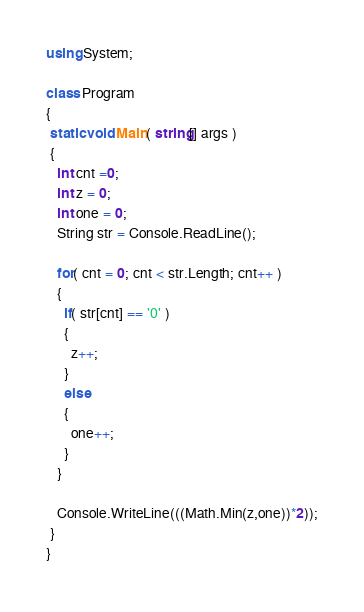Convert code to text. <code><loc_0><loc_0><loc_500><loc_500><_C#_>using System;

class Program
{
 static void Main( string[] args )
 {
   int cnt =0;
   int z = 0;
   int one = 0;
   String str = Console.ReadLine();
   
   for( cnt = 0; cnt < str.Length; cnt++ )
   {
     if( str[cnt] == '0' )
     {
       z++;
     }
     else
     {
       one++;
     }
   }
   
   Console.WriteLine(((Math.Min(z,one))*2));
 }
}
</code> 